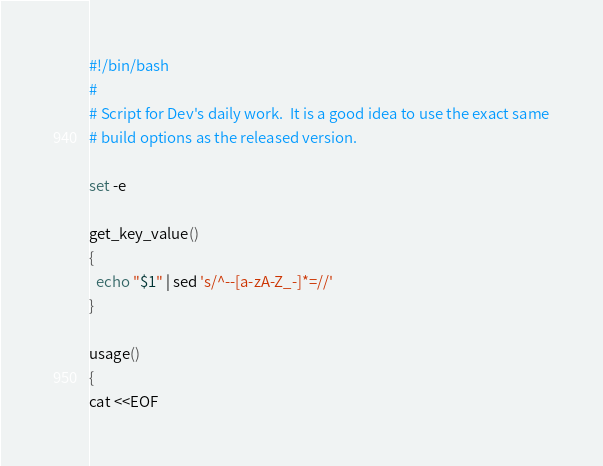<code> <loc_0><loc_0><loc_500><loc_500><_Bash_>#!/bin/bash
#
# Script for Dev's daily work.  It is a good idea to use the exact same
# build options as the released version.

set -e

get_key_value()
{
  echo "$1" | sed 's/^--[a-zA-Z_-]*=//'
}

usage()
{
cat <<EOF</code> 